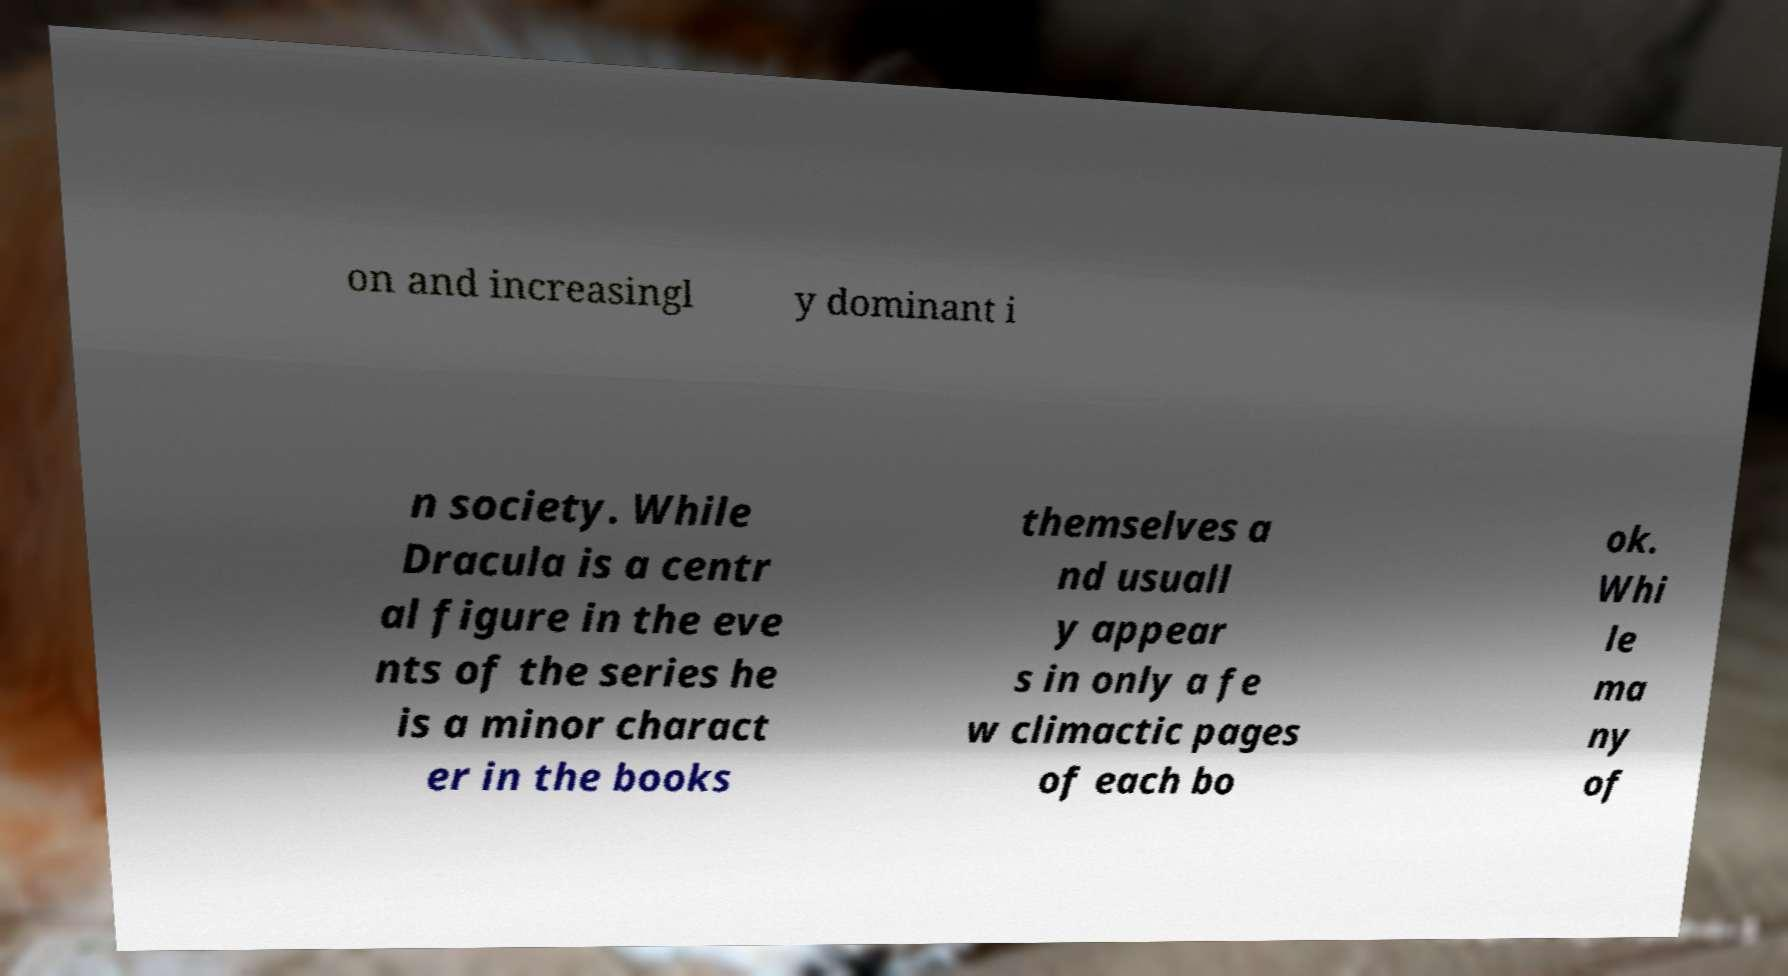What messages or text are displayed in this image? I need them in a readable, typed format. on and increasingl y dominant i n society. While Dracula is a centr al figure in the eve nts of the series he is a minor charact er in the books themselves a nd usuall y appear s in only a fe w climactic pages of each bo ok. Whi le ma ny of 